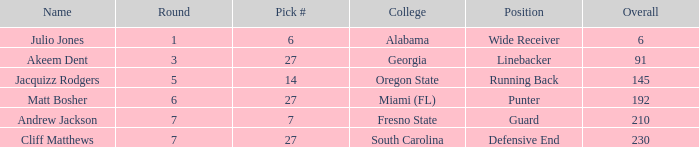Which name had more than 5 rounds and was a defensive end? Cliff Matthews. 